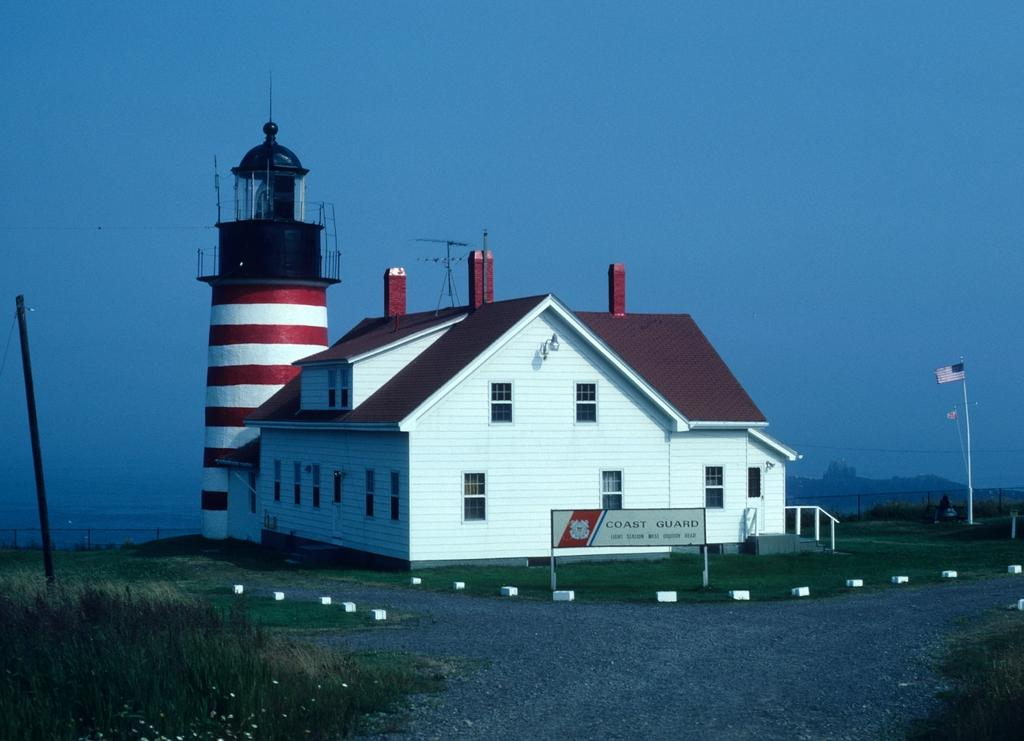What type of structure is visible in the image? There is a house in the image. What is located in front of the house? There is a board and a pole in front of the house. What is visible at the top of the image? The sky is visible at the top of the image. Where is the second pole located in the image? The second pole is on the right side of the image. Can you describe the landscape on the right side of the image? The hill might be visible on the right side of the image. What type of lawyer is standing next to the house in the image? There is no lawyer present in the image; it only features a house, a board, a pole, and possibly a hill. Can you tell me how many dinosaurs are grazing on the hill in the image? There are no dinosaurs present in the image; the hill might be visible, but it does not show any dinosaurs. 